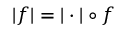<formula> <loc_0><loc_0><loc_500><loc_500>| f | = | \cdot | \circ f</formula> 